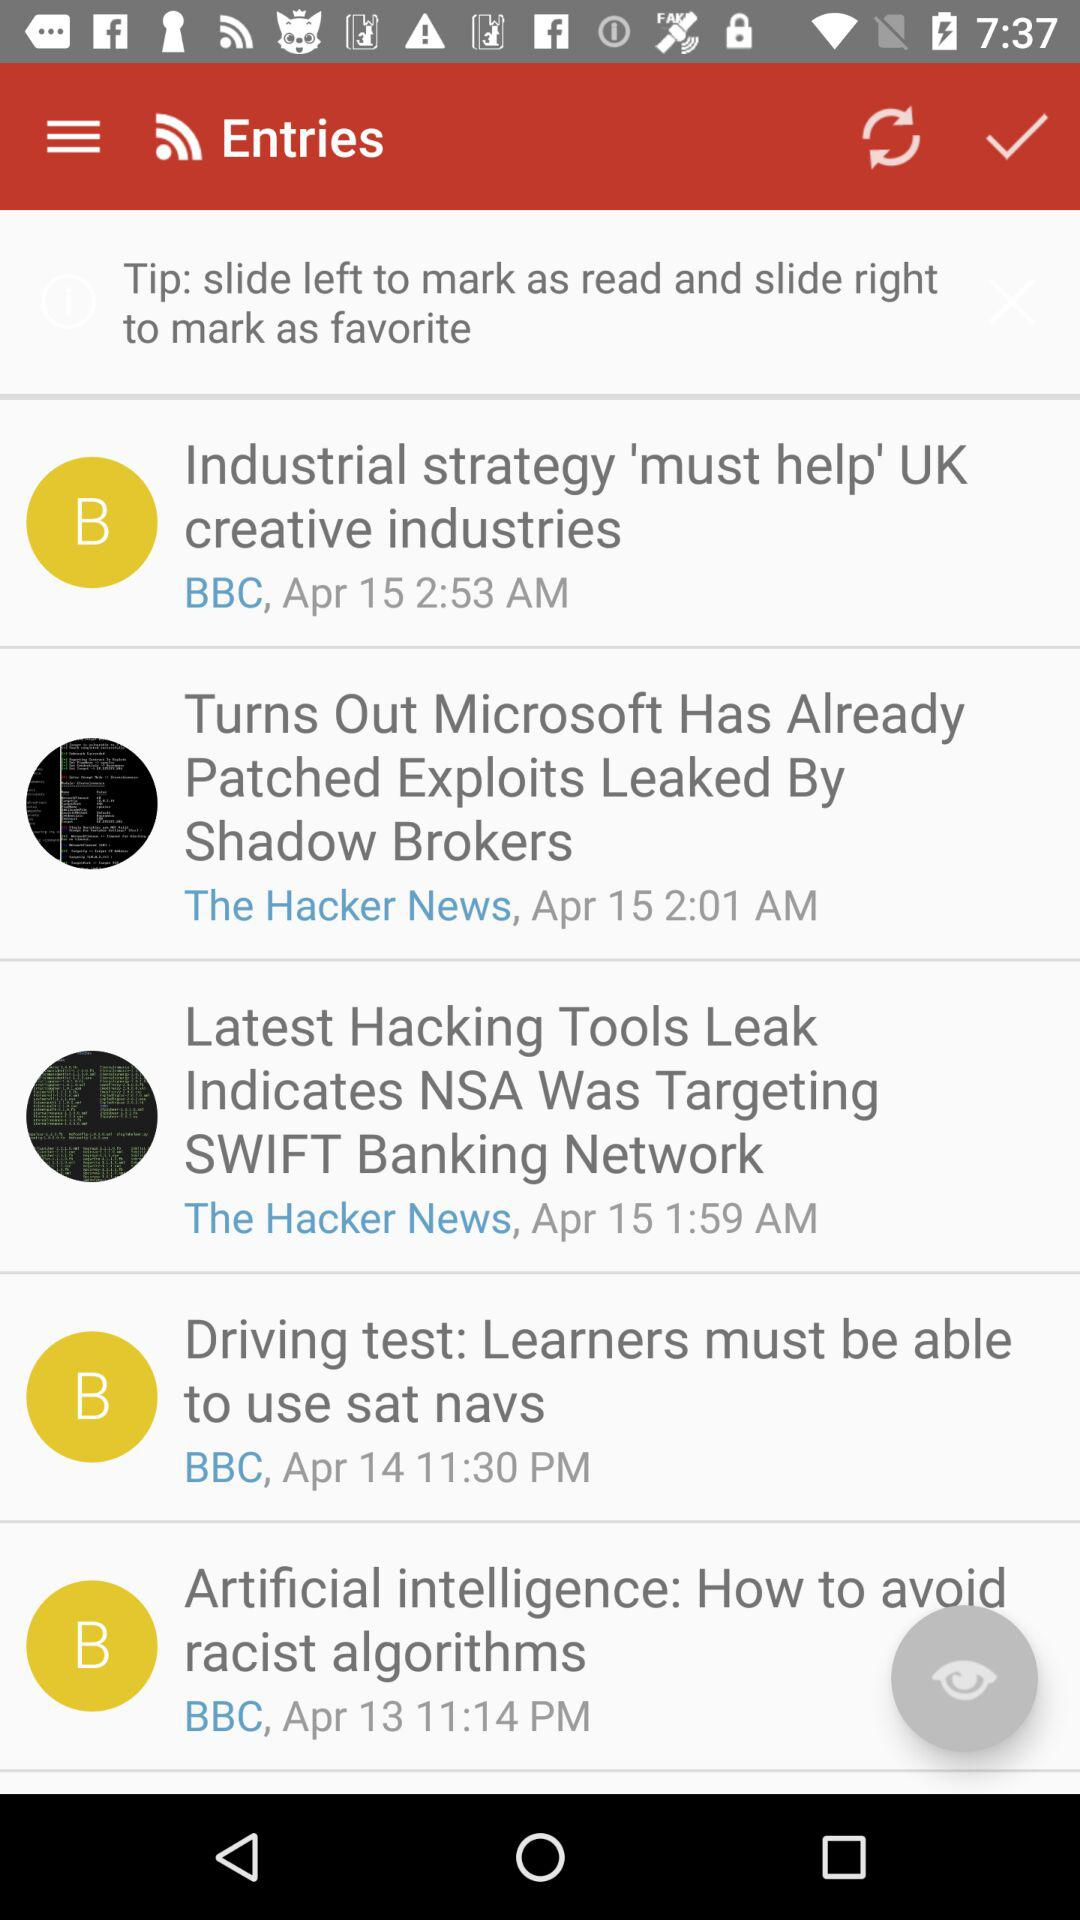When was the entry "Industrial strategy 'must help' UK creative industries" posted? The entry was posted on April 15 at 2:53 AM. 